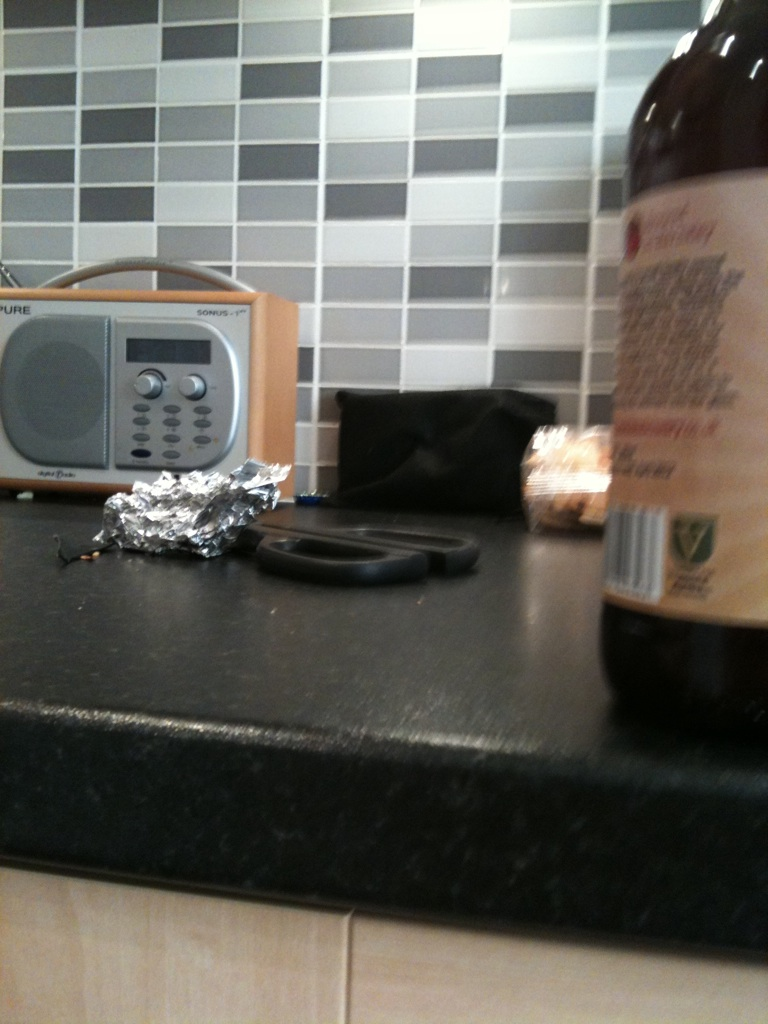Can you describe the overall setting or theme based on the elements shown in the image? The image portrays a homely kitchen counter, adorned with routine household items such as a radio, foil, scissors, and what appears to be a bottle. This cheerful and practical setting embodies a typical everyday domestic scene, emphasizing the household’s functional yet welcoming aura. The presence of a radio suggests a fondness for background music or radio shows during meal preparation or daily chores, while the scattered items imply regular use and a sense of comfort. 